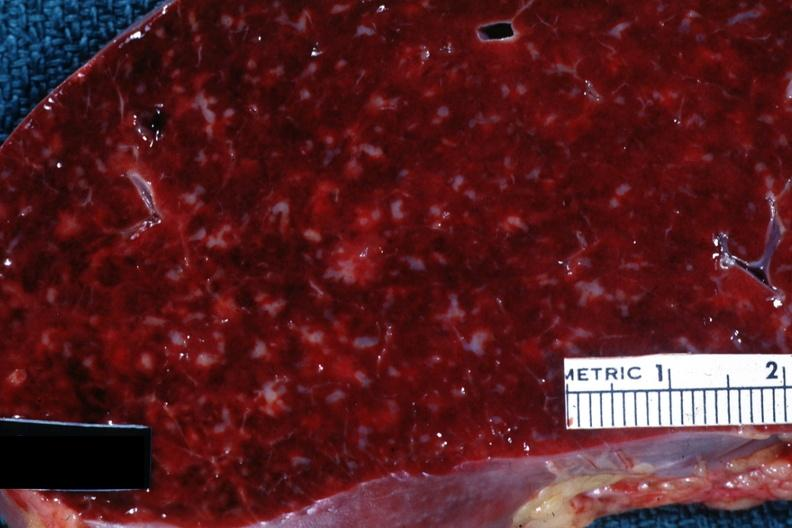does acrocyanosis show close-up with obvious small infiltrates of something?
Answer the question using a single word or phrase. No 